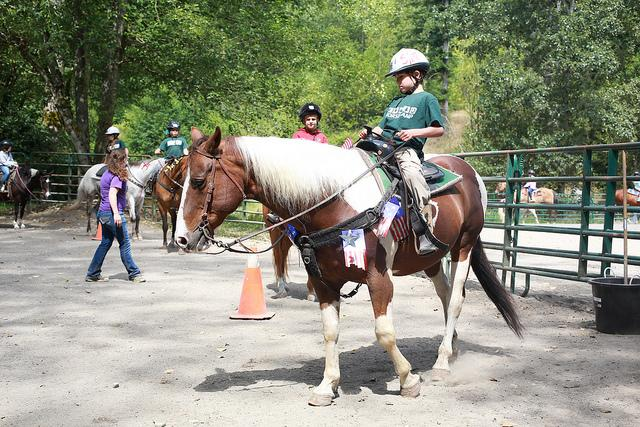Which person works at this facility? purple shirt 